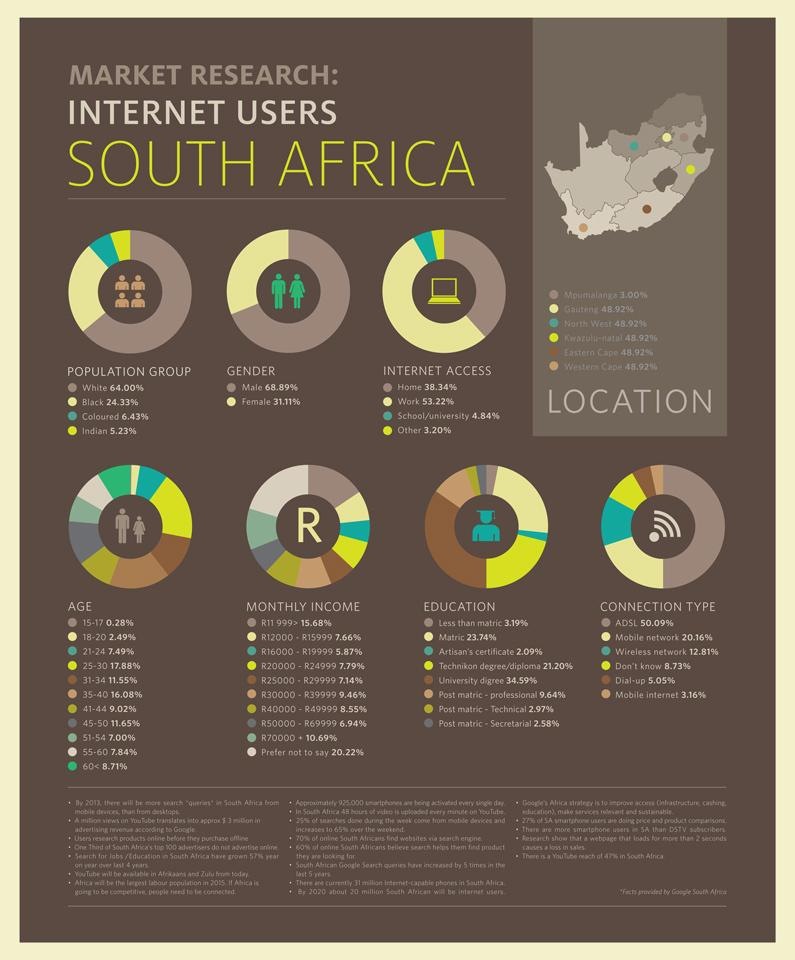Point out several critical features in this image. According to a recent study, 24.33% of internet users in South Africa are black. In South Africa, approximately 38.34% of the population have access to the internet at home. According to a recent survey, only 11.55% of South Africans aged 31-34 years use the internet. In South Africa, the age group with the highest percentage of internet users is 25-30 year olds. In South Africa, 53.22% of the population have access to the internet at work. 